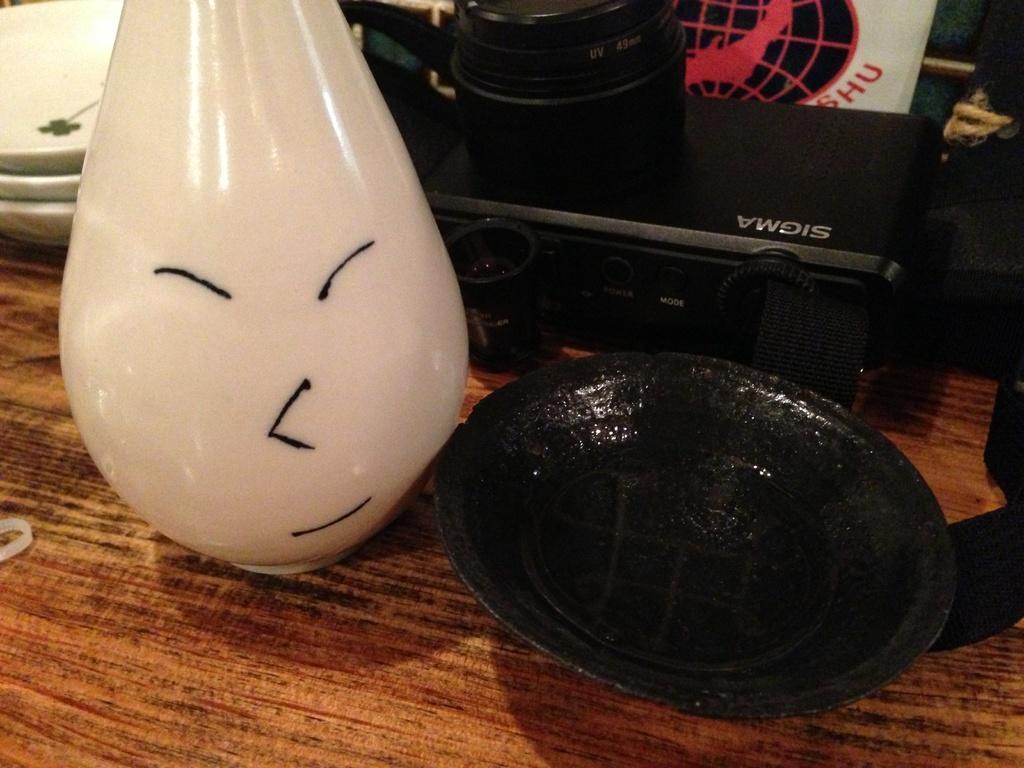Could you give a brief overview of what you see in this image? In this image we can see there are few objects. 